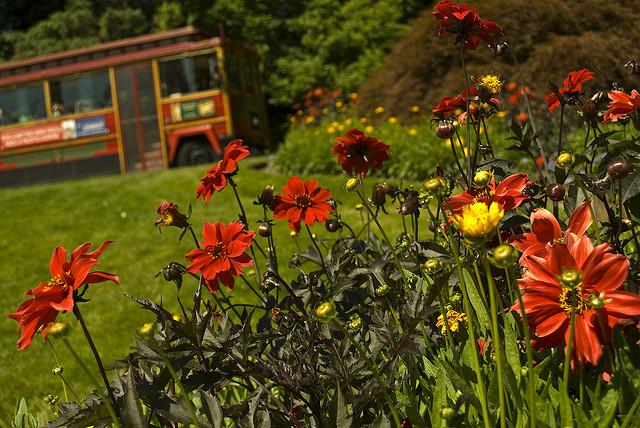What color are the flower petals on the far left?
Answer briefly. Red. What color are the flowers?
Concise answer only. Red. Do you see an electric post?
Short answer required. No. Are the flowers beautiful?
Short answer required. Yes. What color are these flowers?
Quick response, please. Orange. What is holding all the flowers together?
Keep it brief. Stems. Are these summer flowers?
Give a very brief answer. Yes. 